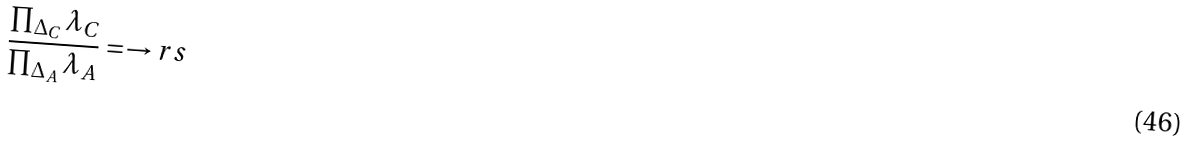Convert formula to latex. <formula><loc_0><loc_0><loc_500><loc_500>\frac { \prod _ { \Delta _ { C } } \lambda _ { C } } { \prod _ { \Delta _ { A } } \lambda _ { A } } = \to r s</formula> 